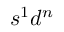Convert formula to latex. <formula><loc_0><loc_0><loc_500><loc_500>s ^ { 1 } d ^ { n }</formula> 